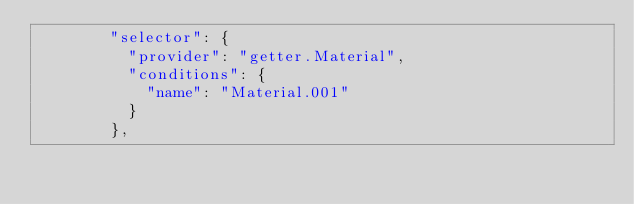<code> <loc_0><loc_0><loc_500><loc_500><_YAML_>        "selector": {
          "provider": "getter.Material",
          "conditions": {
            "name": "Material.001"
          }
        },</code> 